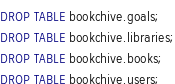Convert code to text. <code><loc_0><loc_0><loc_500><loc_500><_SQL_>DROP TABLE bookchive.goals;
DROP TABLE bookchive.libraries;
DROP TABLE bookchive.books;
DROP TABLE bookchive.users;</code> 